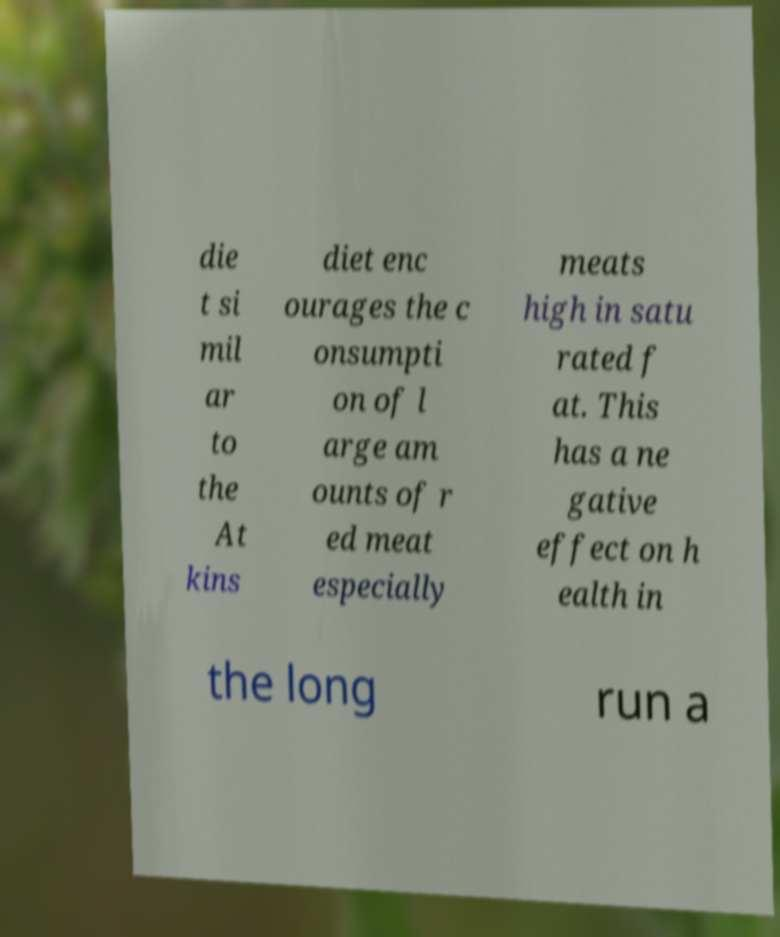Please read and relay the text visible in this image. What does it say? die t si mil ar to the At kins diet enc ourages the c onsumpti on of l arge am ounts of r ed meat especially meats high in satu rated f at. This has a ne gative effect on h ealth in the long run a 